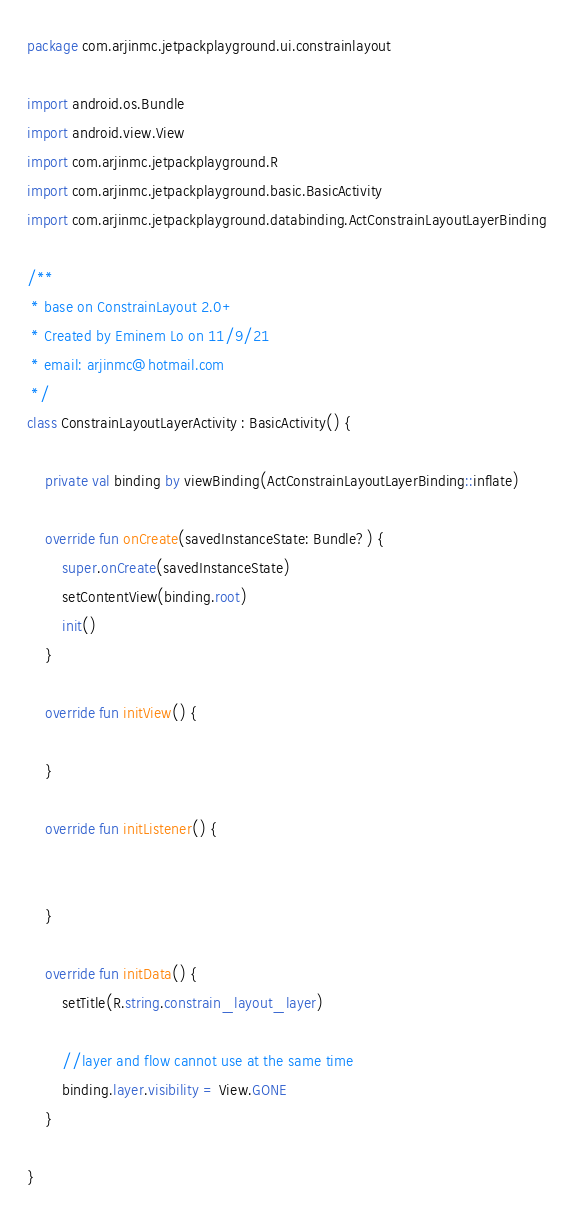<code> <loc_0><loc_0><loc_500><loc_500><_Kotlin_>package com.arjinmc.jetpackplayground.ui.constrainlayout

import android.os.Bundle
import android.view.View
import com.arjinmc.jetpackplayground.R
import com.arjinmc.jetpackplayground.basic.BasicActivity
import com.arjinmc.jetpackplayground.databinding.ActConstrainLayoutLayerBinding

/**
 * base on ConstrainLayout 2.0+
 * Created by Eminem Lo on 11/9/21
 * email: arjinmc@hotmail.com
 */
class ConstrainLayoutLayerActivity : BasicActivity() {

    private val binding by viewBinding(ActConstrainLayoutLayerBinding::inflate)

    override fun onCreate(savedInstanceState: Bundle?) {
        super.onCreate(savedInstanceState)
        setContentView(binding.root)
        init()
    }

    override fun initView() {

    }

    override fun initListener() {


    }

    override fun initData() {
        setTitle(R.string.constrain_layout_layer)

        //layer and flow cannot use at the same time
        binding.layer.visibility = View.GONE
    }

}
</code> 